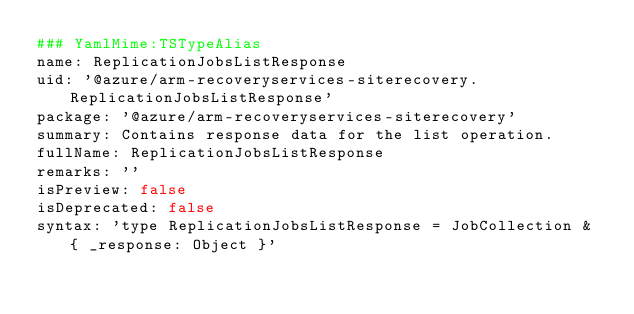Convert code to text. <code><loc_0><loc_0><loc_500><loc_500><_YAML_>### YamlMime:TSTypeAlias
name: ReplicationJobsListResponse
uid: '@azure/arm-recoveryservices-siterecovery.ReplicationJobsListResponse'
package: '@azure/arm-recoveryservices-siterecovery'
summary: Contains response data for the list operation.
fullName: ReplicationJobsListResponse
remarks: ''
isPreview: false
isDeprecated: false
syntax: 'type ReplicationJobsListResponse = JobCollection & { _response: Object }'
</code> 